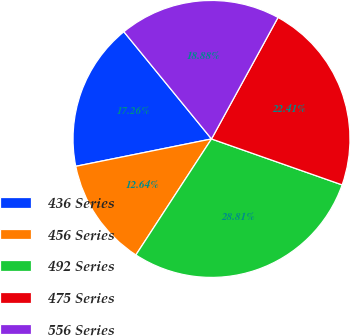<chart> <loc_0><loc_0><loc_500><loc_500><pie_chart><fcel>436 Series<fcel>456 Series<fcel>492 Series<fcel>475 Series<fcel>556 Series<nl><fcel>17.26%<fcel>12.64%<fcel>28.81%<fcel>22.41%<fcel>18.88%<nl></chart> 